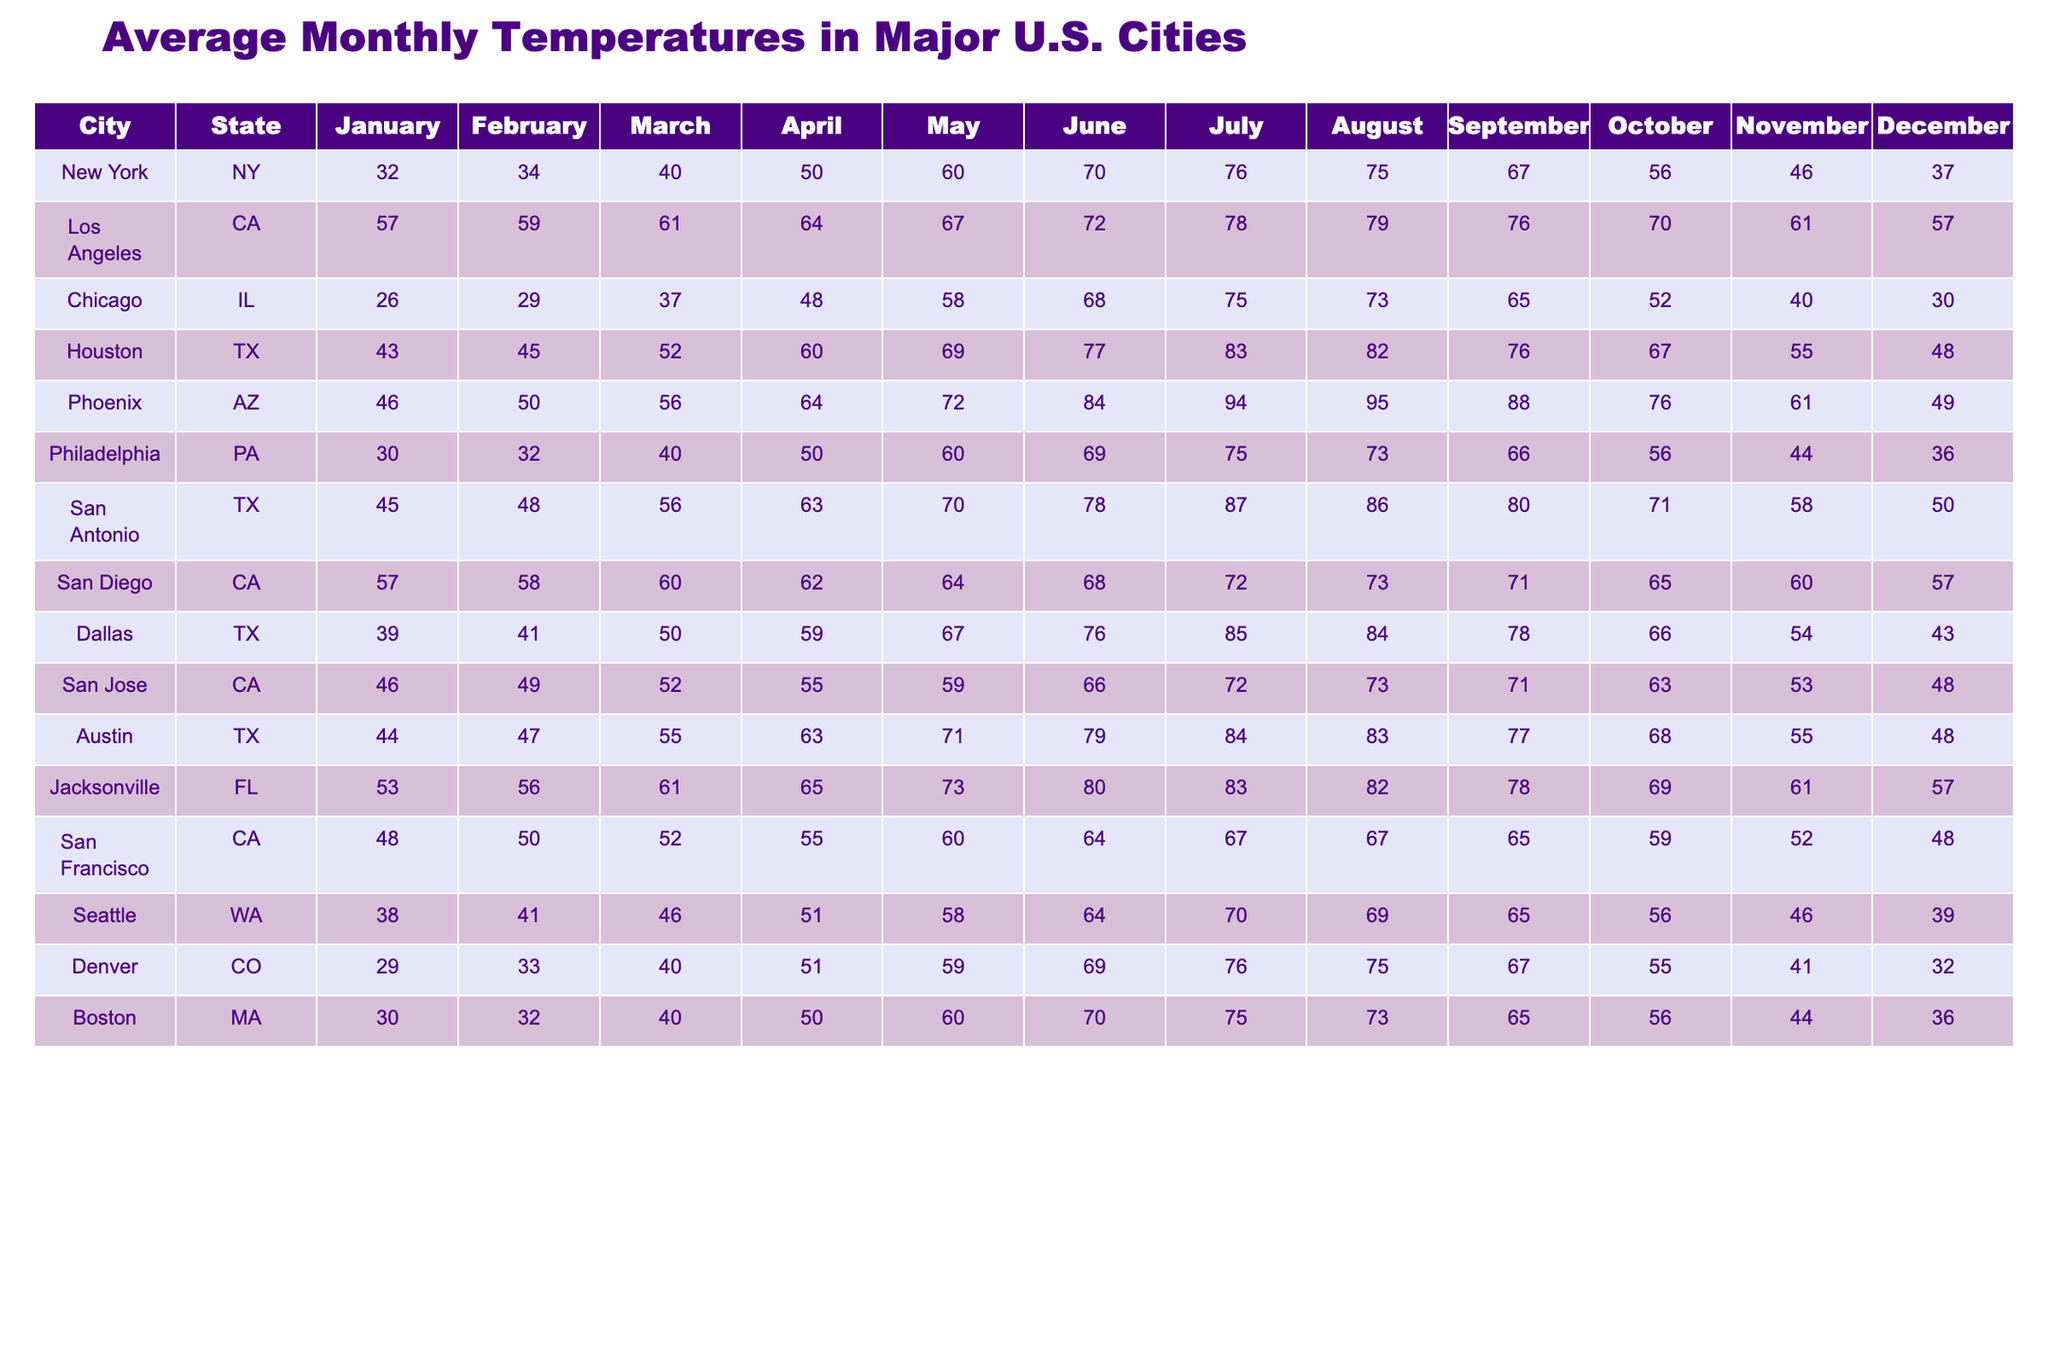What is the average temperature in New York in July? For New York, the temperature in July is 76°F. There are no calculations needed here as we are retrieving a specific value directly from the table.
Answer: 76°F Which city has the highest temperature in August? In the table, the temperatures for August are compared: Los Angeles has 79°F, Houston 82°F, Phoenix 95°F, and San Antonio 86°F. The highest value is 95°F from Phoenix.
Answer: Phoenix What is the temperature difference between January and July in Chicago? In January, Chicago's temperature is 26°F, and in July, it is 75°F. The difference is calculated as 75 - 26 = 49°F.
Answer: 49°F What is the average temperature for the month of June across all cities? To find the average for June, we take each city's June temperature (70, 72, 68, 77, 84, 69, 78, 68, 79, 80, 64, 69) which sums up to 837. There are 12 cities, so the average is 837 / 12 = 69.75°F.
Answer: 69.75°F Is the temperature in San Diego higher or lower in December compared to January? In December, San Diego is 57°F, and in January, it is 57°F as well. Comparing the two, they are equal.
Answer: Equal Which city has the lowest temperature in December? Looking at December temperatures, New York is 37°F, Chicago is 30°F, and Seattle is 39°F. The lowest is from Chicago with 30°F.
Answer: Chicago What is the median temperature in October across the cities listed? To find the median, we list the October temperatures in order: 37, 43, 48, 49, 52, 56, 56, 61, 66, 70, 73, 76. The median is the average of the 6th and 7th values (56 and 61), which is (56 + 61) / 2 = 58.5°F.
Answer: 58.5°F What is the average temperature for San Antonio over the year? The temperatures for San Antonio each month are 45, 48, 56, 63, 70, 78, 87, 86, 80, 71, 58, 50. The total is 705, and dividing by 12 gives us an average of 58.75°F.
Answer: 58.75°F Which month has the highest average temperature in Los Angeles? The temperatures in Los Angeles from January to December are: 57, 59, 61, 64, 67, 72, 78, 79, 76, 70, 61, 57. The highest value is 79°F in August.
Answer: August Do more cities have a temperature above 70°F in July or June? In July, the cities with temperatures above 70°F are New York, Los Angeles, Houston, Phoenix, San Antonio, San Diego, Austin, and Jacksonville. In June, the same cities apply. Counting both months, 8 cities are above 70°F in both, showing equality.
Answer: Equal 